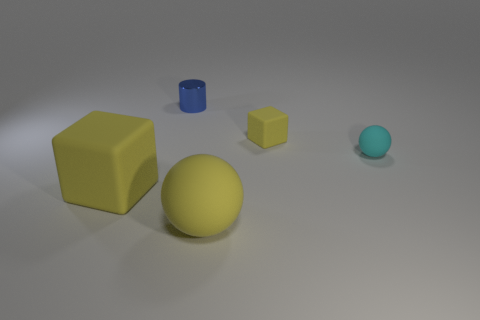How many objects are either small cyan matte things that are right of the tiny yellow cube or big objects on the left side of the small cyan rubber object?
Ensure brevity in your answer.  3. What number of objects are either big things or rubber spheres behind the large yellow rubber ball?
Your answer should be compact. 3. There is a yellow thing that is behind the yellow cube that is to the left of the matte thing that is in front of the big yellow block; what size is it?
Provide a short and direct response. Small. There is a cyan thing that is the same size as the blue object; what is its material?
Your answer should be compact. Rubber. Is there a metallic sphere that has the same size as the blue metal object?
Your answer should be very brief. No. There is a matte cube that is to the left of the shiny cylinder; is it the same size as the large yellow ball?
Offer a very short reply. Yes. The tiny object that is both in front of the tiny shiny object and on the left side of the tiny cyan matte object has what shape?
Keep it short and to the point. Cube. Is the number of small objects that are to the right of the big yellow rubber sphere greater than the number of yellow blocks?
Give a very brief answer. No. What size is the yellow sphere that is made of the same material as the big yellow cube?
Provide a succinct answer. Large. What number of big balls are the same color as the large matte cube?
Provide a succinct answer. 1. 